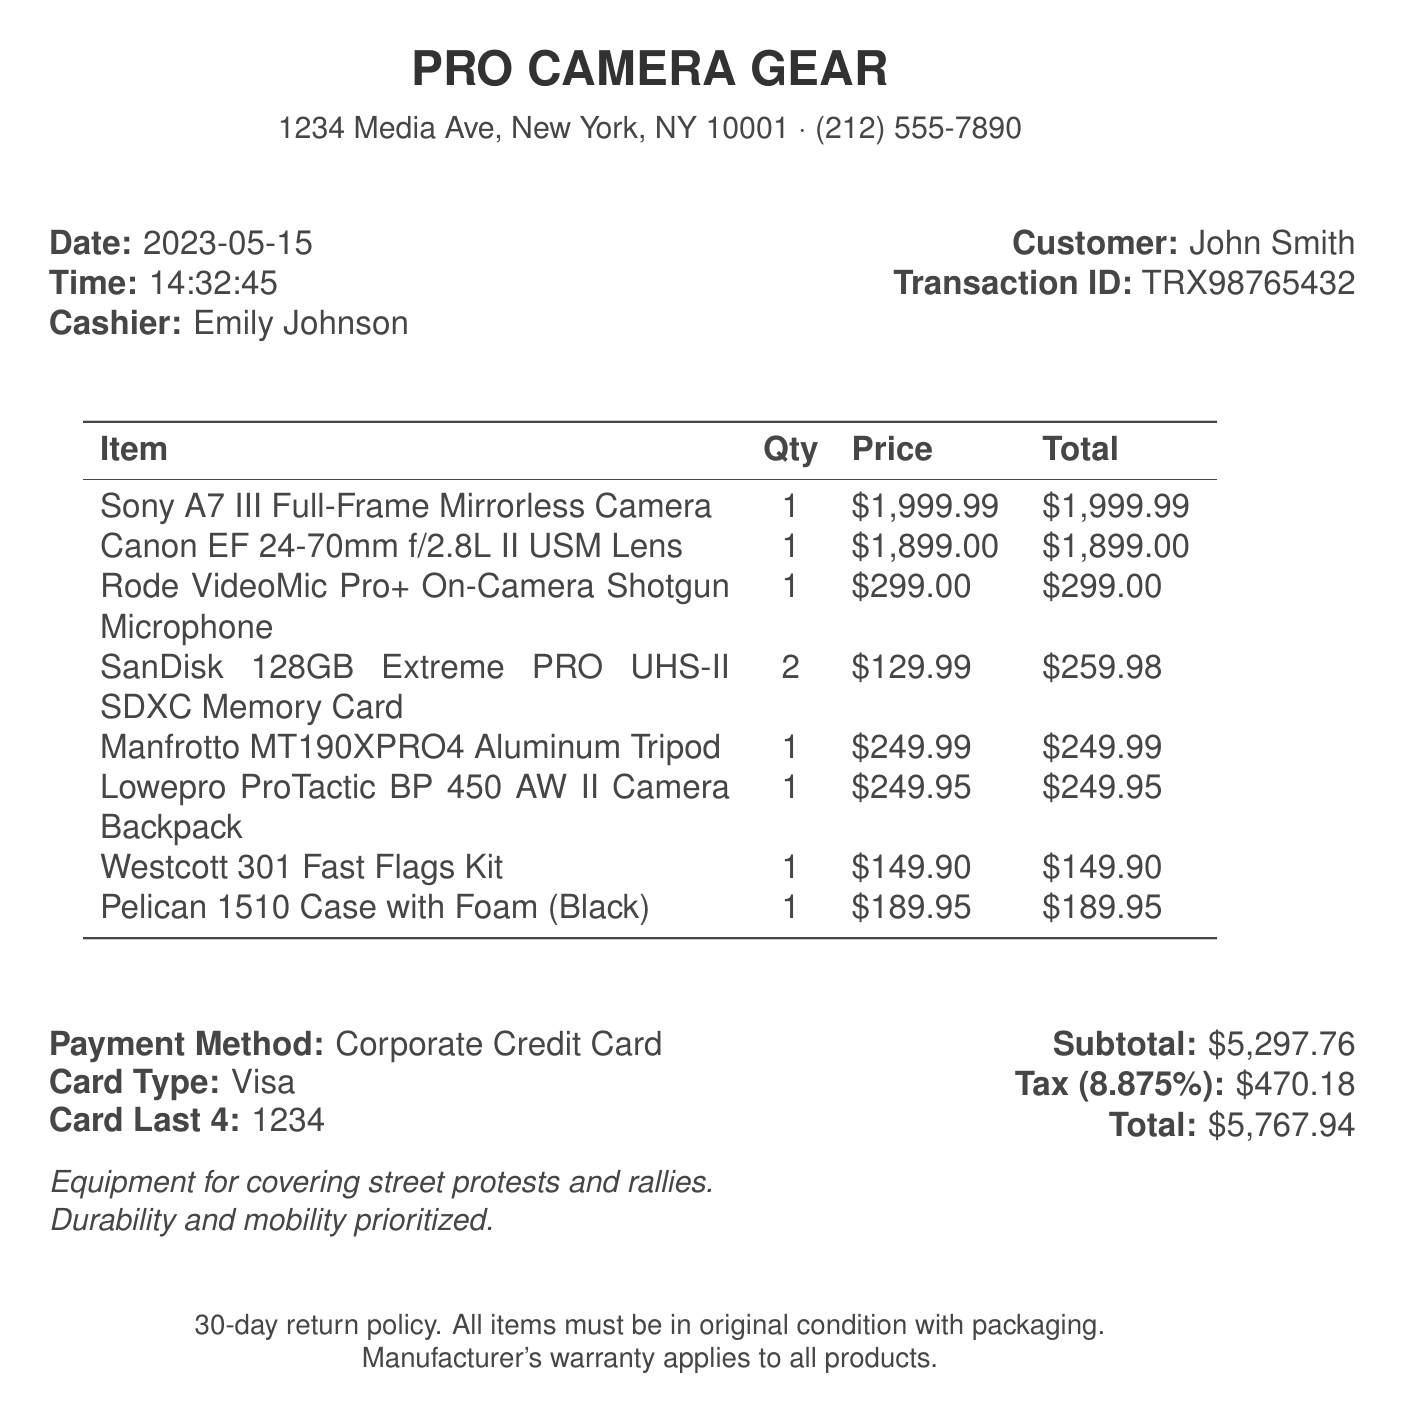What is the date of the purchase? The date of the purchase is specified in the document as the time of the transaction.
Answer: 2023-05-15 Who was the cashier? The cashier's name is stated in the receipt, crucial for customer service reference.
Answer: Emily Johnson What is the total amount spent? The total amount is calculated including the subtotal and tax indicated in the receipt.
Answer: $5,767.94 How many items were purchased? The total number of items can be counted from the list provided in the document.
Answer: 8 What is the warranty policy? The document specifies what type of warranty applies to the purchased items.
Answer: Manufacturer's warranty What items are included in the purchase? The specific items listed provide detailed context about the purchase's purpose.
Answer: Camera equipment and accessories What payment method was used? The document clearly states the payment method used for this transaction.
Answer: Corporate Credit Card What is the tax rate applied? The tax rate is specified as a decimal percentage in the document, which is important for calculating total costs.
Answer: 8.875% What is the store address? The address of the store is essential for any follow-up or inquiries regarding the purchase.
Answer: 1234 Media Ave, New York, NY 10001 